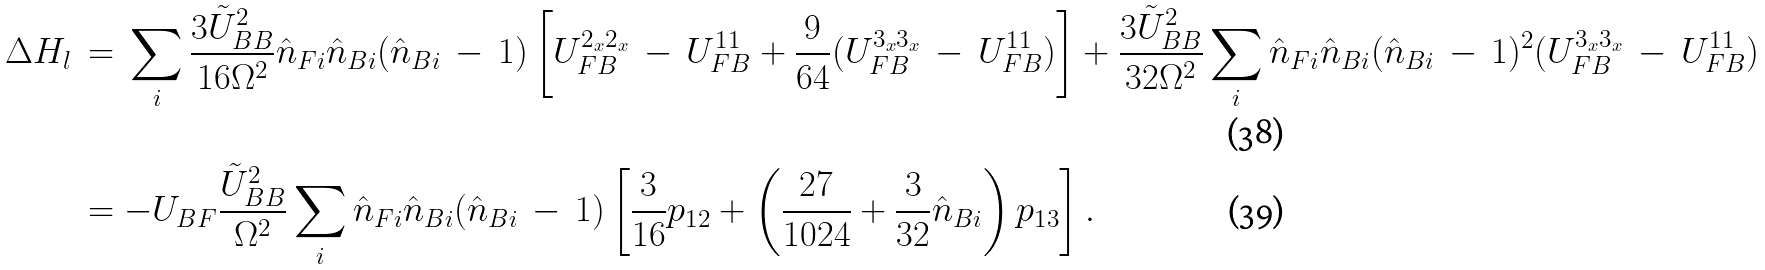<formula> <loc_0><loc_0><loc_500><loc_500>\Delta H _ { l } \, & = \, \sum _ { i } \frac { 3 \tilde { U } _ { B B } ^ { 2 } } { 1 6 \Omega ^ { 2 } } \hat { n } _ { F i } \hat { n } _ { B i } ( \hat { n } _ { B i } \, - \, 1 ) \left [ U _ { F B } ^ { 2 _ { x } 2 _ { x } } \, - \, U _ { F B } ^ { 1 1 } + \frac { 9 } { 6 4 } ( U _ { F B } ^ { 3 _ { x } 3 _ { x } } \, - \, U _ { F B } ^ { 1 1 } ) \right ] + \frac { 3 \tilde { U } _ { B B } ^ { 2 } } { 3 2 \Omega ^ { 2 } } \sum _ { i } \hat { n } _ { F i } \hat { n } _ { B i } ( \hat { n } _ { B i } \, - \, 1 ) ^ { 2 } ( U _ { F B } ^ { 3 _ { x } 3 _ { x } } \, - \, U _ { F B } ^ { 1 1 } ) \\ & = - U _ { B F } \frac { \tilde { U } _ { B B } ^ { 2 } } { \Omega ^ { 2 } } \sum _ { i } \hat { n } _ { F i } \hat { n } _ { B i } ( \hat { n } _ { B i } \, - \, 1 ) \left [ \frac { 3 } { 1 6 } p _ { 1 2 } + \left ( \frac { 2 7 } { 1 0 2 4 } + \frac { 3 } { 3 2 } \hat { n } _ { B i } \right ) p _ { 1 3 } \right ] .</formula> 